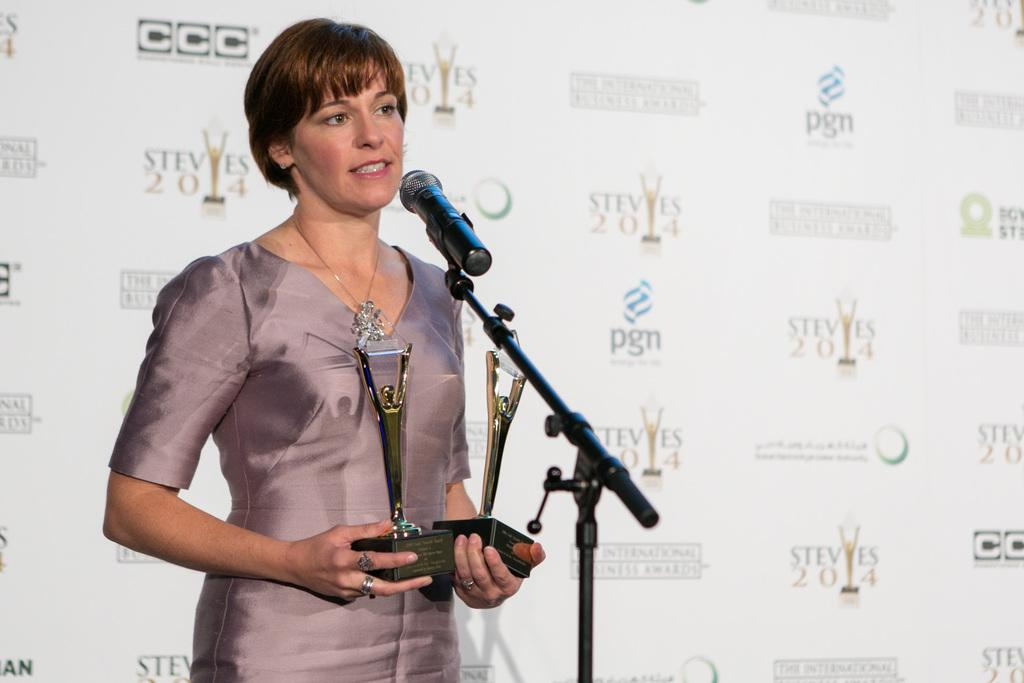Who is the main subject in the image? There is a woman in the image. What is the woman doing in the image? The woman is standing in front of a microphone. What is the woman holding in the image? The woman is holding shields. What can be seen in the background of the image? There is a hoarding visible in the background of the image. What type of foot is visible in the image? There is no foot visible in the image. What type of market is depicted in the image? There is no market depicted in the image. 